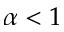Convert formula to latex. <formula><loc_0><loc_0><loc_500><loc_500>\alpha < 1</formula> 